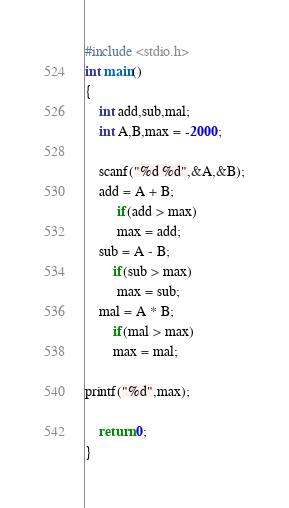Convert code to text. <code><loc_0><loc_0><loc_500><loc_500><_C_>#include <stdio.h>
int main()
{
    int add,sub,mal;
    int A,B,max = -2000;

    scanf("%d %d",&A,&B);
    add = A + B;
         if(add > max)
         max = add;
    sub = A - B;
        if(sub > max)
         max = sub;
    mal = A * B;
        if(mal > max)
        max = mal;

printf("%d",max);

    return 0;
}</code> 